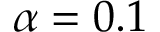<formula> <loc_0><loc_0><loc_500><loc_500>\alpha = 0 . 1</formula> 